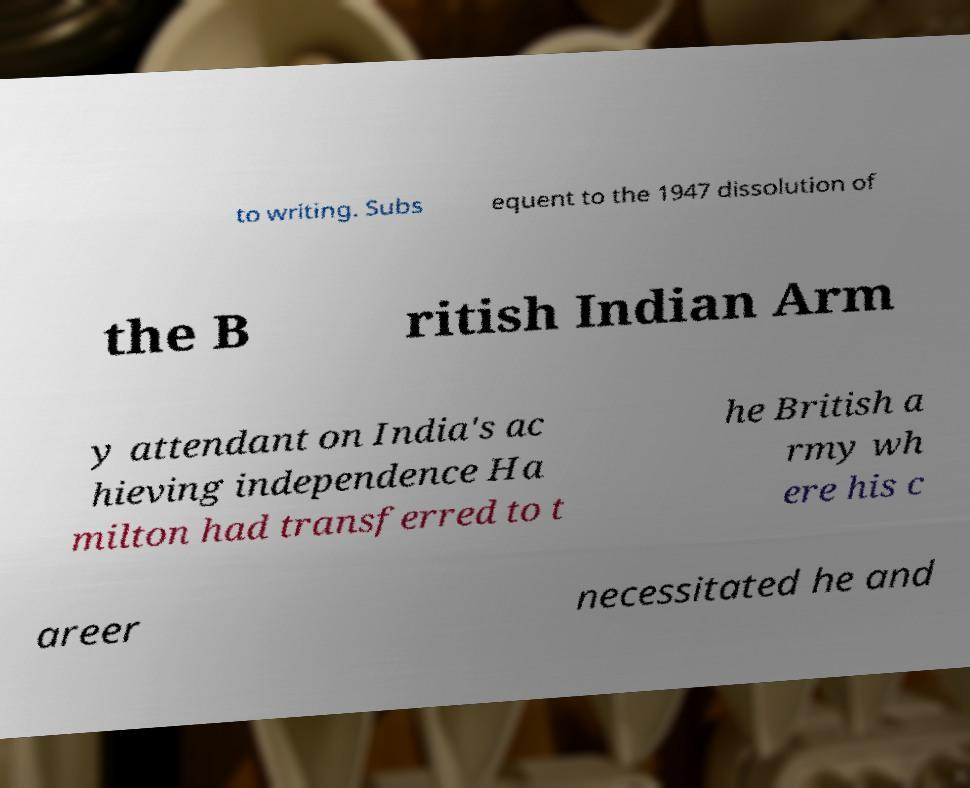I need the written content from this picture converted into text. Can you do that? to writing. Subs equent to the 1947 dissolution of the B ritish Indian Arm y attendant on India's ac hieving independence Ha milton had transferred to t he British a rmy wh ere his c areer necessitated he and 